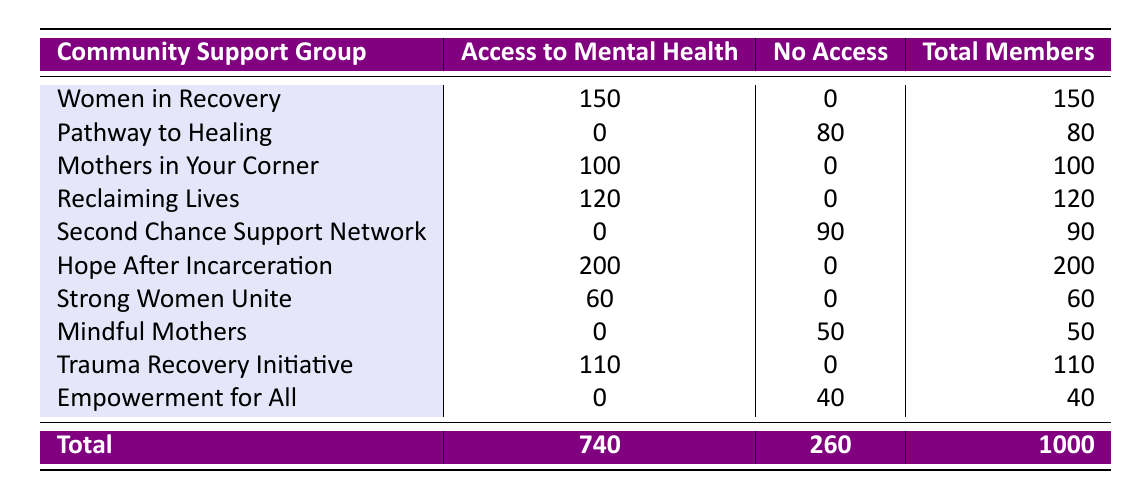What is the total number of members with access to mental health resources? To find the total, we need to sum the number of members from each community support group that offers access to mental health resources. By adding 150 (Women in Recovery) + 100 (Mothers in Your Corner) + 120 (Reclaiming Lives) + 200 (Hope After Incarceration) + 60 (Strong Women Unite) + 110 (Trauma Recovery Initiative), we get 150 + 100 + 120 + 200 + 60 + 110 = 740.
Answer: 740 How many community support groups do not have access to mental health resources? Looking at the table, we can identify the groups that lack access: Pathway to Healing, Second Chance Support Network, Mindful Mothers, and Empowerment for All. This gives us a total of 4 groups.
Answer: 4 What is the member count of the community support group with the highest access to mental health resources? By inspecting the table for the highest member count with access, we see that "Hope After Incarceration" has 200 members, which is more than any other group listed.
Answer: 200 Calculate the difference in total members between groups with access and those without. First, we calculate total members with access, which is 740. For groups without access, we add 80 (Pathway to Healing) + 90 (Second Chance Support Network) + 50 (Mindful Mothers) + 40 (Empowerment for All) = 260 members. The difference is 740 - 260 = 480.
Answer: 480 Is "Strong Women Unite" associated with access to mental health resources? By checking the table, we see that "Strong Women Unite" has access to mental health resources, so the answer is yes.
Answer: Yes What percentage of the total members have access to mental health resources? To find the percentage, we divide the total members with access (740) by the total number of members (1000) and multiply by 100. This gives (740/1000) * 100 = 74%.
Answer: 74% Which community support group has the least number of members with access to mental health resources, and what is that number? By examining the groups with access, we find that "Strong Women Unite" has 60 members, which is less than the others with access (150, 100, 120, 200, and 110). Therefore, the least is 60 members from "Strong Women Unite."
Answer: Strong Women Unite, 60 How many members are in the "Mindful Mothers" group, and do they have access to mental health resources? According to the table, "Mindful Mothers" has 50 members and does not have access to mental health resources, as indicated by the 'No' in the corresponding column.
Answer: 50, No 